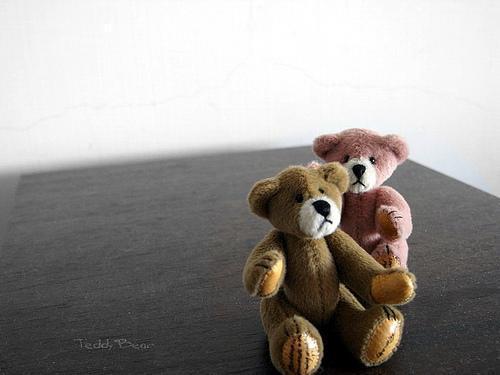How many bears are there?
Give a very brief answer. 2. How many teddy bears are in the photo?
Give a very brief answer. 2. How many bikes are behind the clock?
Give a very brief answer. 0. 